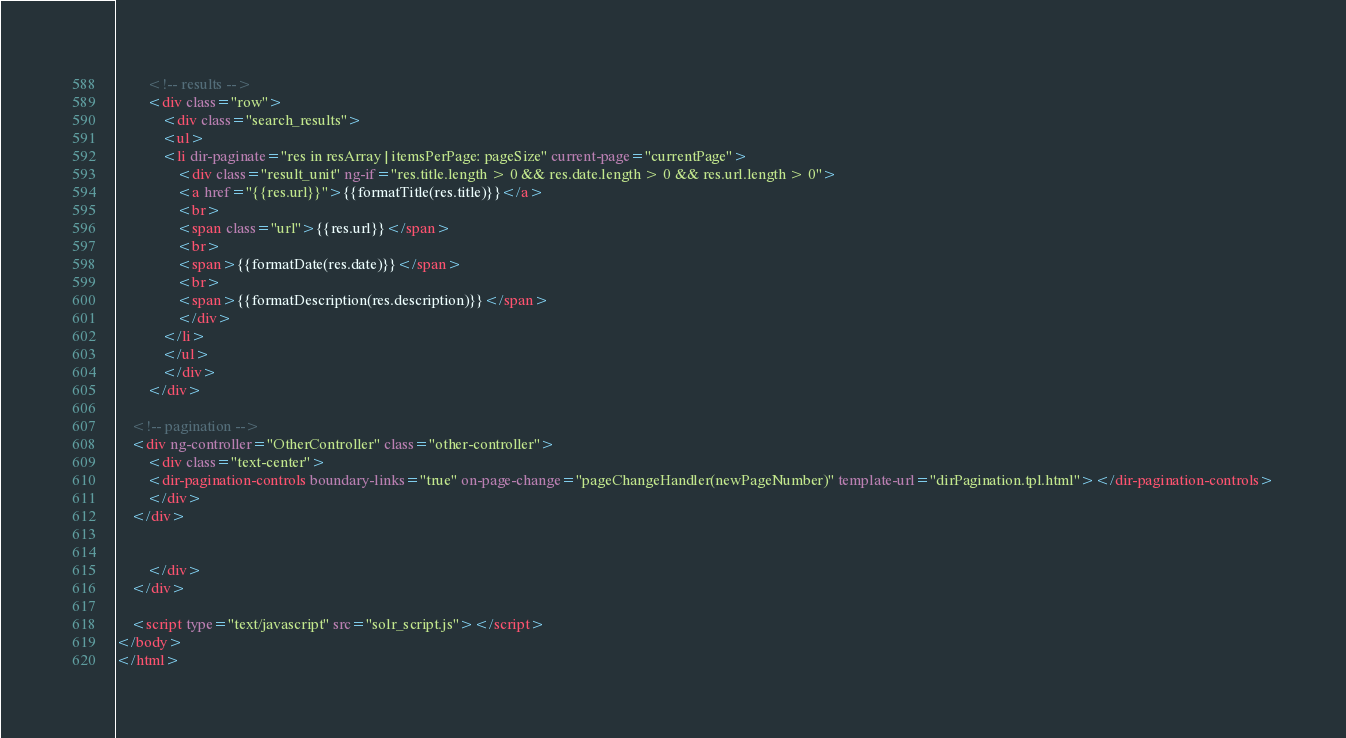Convert code to text. <code><loc_0><loc_0><loc_500><loc_500><_HTML_>        <!-- results -->
        <div class="row">
            <div class="search_results">
            <ul>
            <li dir-paginate="res in resArray | itemsPerPage: pageSize" current-page="currentPage">
                <div class="result_unit" ng-if="res.title.length > 0 && res.date.length > 0 && res.url.length > 0">
                <a href="{{res.url}}">{{formatTitle(res.title)}}</a>
                <br>
                <span class="url">{{res.url}}</span>
                <br>
                <span>{{formatDate(res.date)}}</span>
                <br>
                <span>{{formatDescription(res.description)}}</span>
                </div>
            </li>
            </ul>    
            </div>
        </div>
    
    <!-- pagination -->
    <div ng-controller="OtherController" class="other-controller">
        <div class="text-center">
        <dir-pagination-controls boundary-links="true" on-page-change="pageChangeHandler(newPageNumber)" template-url="dirPagination.tpl.html"></dir-pagination-controls>
        </div>
    </div>
        
            
        </div>
    </div>
    
    <script type="text/javascript" src="solr_script.js"></script>
</body>
</html></code> 